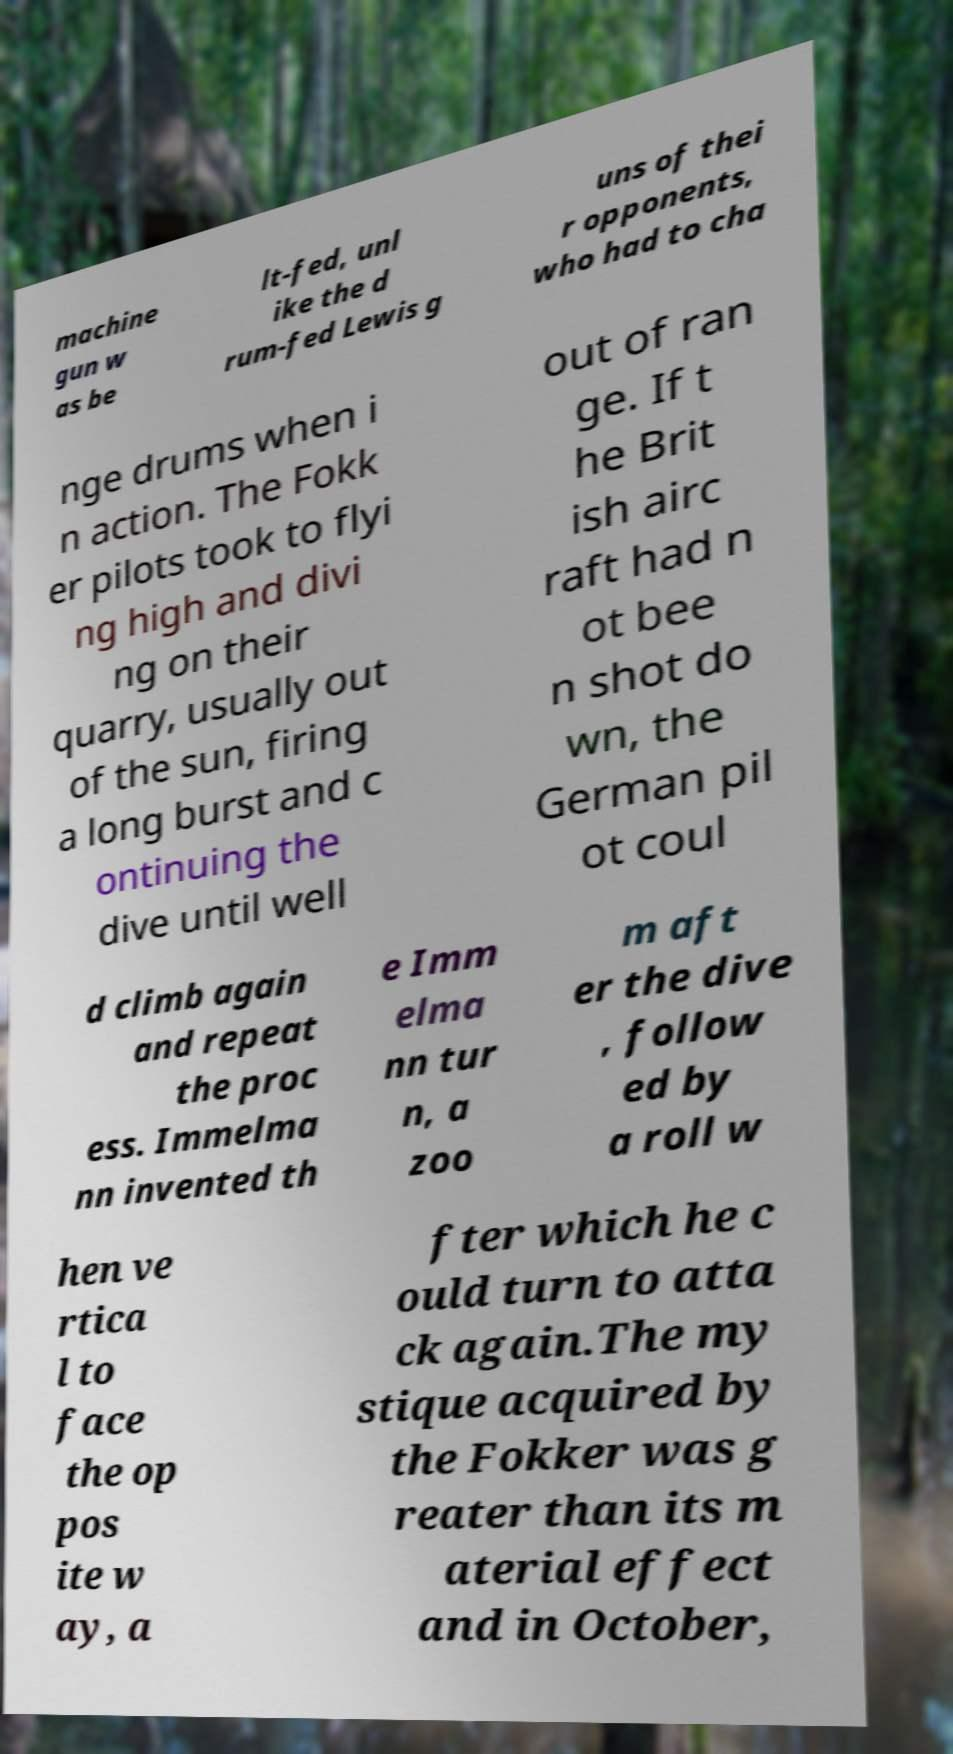Please read and relay the text visible in this image. What does it say? machine gun w as be lt-fed, unl ike the d rum-fed Lewis g uns of thei r opponents, who had to cha nge drums when i n action. The Fokk er pilots took to flyi ng high and divi ng on their quarry, usually out of the sun, firing a long burst and c ontinuing the dive until well out of ran ge. If t he Brit ish airc raft had n ot bee n shot do wn, the German pil ot coul d climb again and repeat the proc ess. Immelma nn invented th e Imm elma nn tur n, a zoo m aft er the dive , follow ed by a roll w hen ve rtica l to face the op pos ite w ay, a fter which he c ould turn to atta ck again.The my stique acquired by the Fokker was g reater than its m aterial effect and in October, 